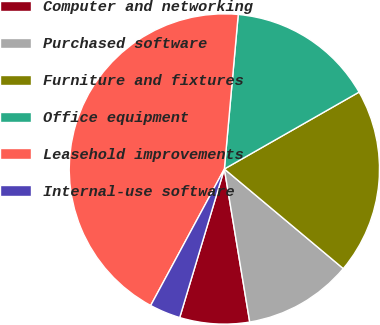Convert chart to OTSL. <chart><loc_0><loc_0><loc_500><loc_500><pie_chart><fcel>Computer and networking<fcel>Purchased software<fcel>Furniture and fixtures<fcel>Office equipment<fcel>Leasehold improvements<fcel>Internal-use software<nl><fcel>7.26%<fcel>11.29%<fcel>19.35%<fcel>15.32%<fcel>43.55%<fcel>3.23%<nl></chart> 